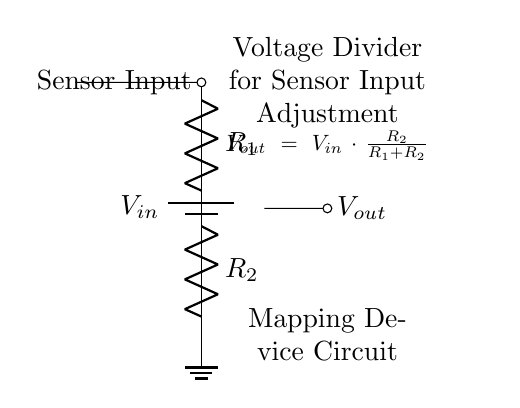What is the purpose of the voltage divider? The voltage divider is used to adjust the sensor input levels in mapping devices by dividing the input voltage into a lower output voltage.
Answer: Adjust sensor input What are the resistor values in the circuit? The values of the resistors are indicated as R1 and R2, but specific numerical values are not provided in the diagram. They are typically chosen based on desired output voltage.
Answer: R1 and R2 What is the equation for the output voltage? The output voltage is given by the equation Vout = Vin * (R2 / (R1 + R2)), which defines how much of the input voltage appears at the output, based on the resistor values.
Answer: Vout = Vin * (R2 / (R1 + R2)) Which component is connected to ground? The bottom terminal of resistor R2 is connected to ground, indicating the reference point in this voltage divider circuit.
Answer: R2 If R1 is doubled, what happens to Vout? If R1 is doubled, the output voltage Vout decreases, because the ratio R2 / (R1 + R2) becomes smaller, reducing the output voltage derived from Vin.
Answer: Vout decreases What is the role of Vin in this circuit? Vin is the input voltage supplied to the circuit, which is divided between the resistors to provide a specific output voltage at Vout for the sensor input.
Answer: Input voltage 